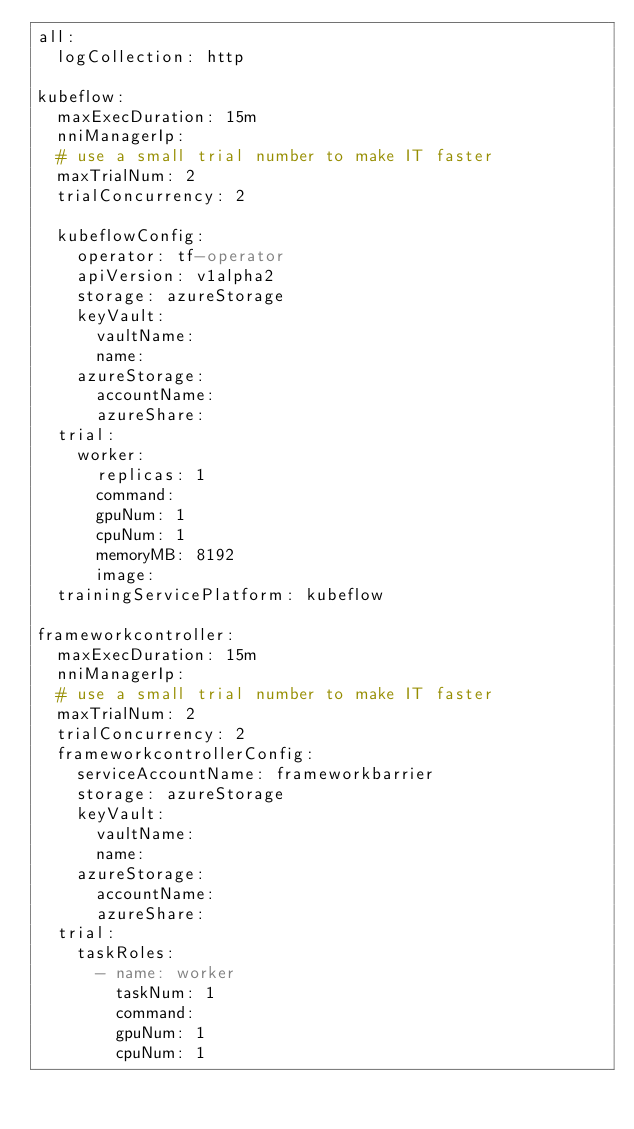<code> <loc_0><loc_0><loc_500><loc_500><_YAML_>all:
  logCollection: http

kubeflow:
  maxExecDuration: 15m
  nniManagerIp:
  # use a small trial number to make IT faster
  maxTrialNum: 2
  trialConcurrency: 2

  kubeflowConfig:
    operator: tf-operator
    apiVersion: v1alpha2
    storage: azureStorage
    keyVault:
      vaultName:
      name:
    azureStorage:
      accountName:
      azureShare:
  trial:
    worker:
      replicas: 1
      command:
      gpuNum: 1
      cpuNum: 1
      memoryMB: 8192
      image:
  trainingServicePlatform: kubeflow

frameworkcontroller:
  maxExecDuration: 15m
  nniManagerIp:
  # use a small trial number to make IT faster
  maxTrialNum: 2
  trialConcurrency: 2
  frameworkcontrollerConfig:
    serviceAccountName: frameworkbarrier
    storage: azureStorage
    keyVault:
      vaultName:
      name:
    azureStorage:
      accountName:
      azureShare:
  trial:
    taskRoles:
      - name: worker
        taskNum: 1
        command:
        gpuNum: 1
        cpuNum: 1</code> 